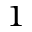<formula> <loc_0><loc_0><loc_500><loc_500>^ { 1 }</formula> 